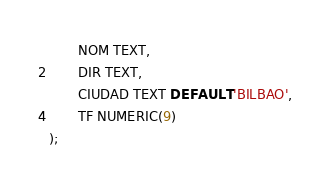Convert code to text. <code><loc_0><loc_0><loc_500><loc_500><_SQL_>       NOM TEXT,
       DIR TEXT,
       CIUDAD TEXT DEFAULT 'BILBAO',
       TF NUMERIC(9)
);
</code> 